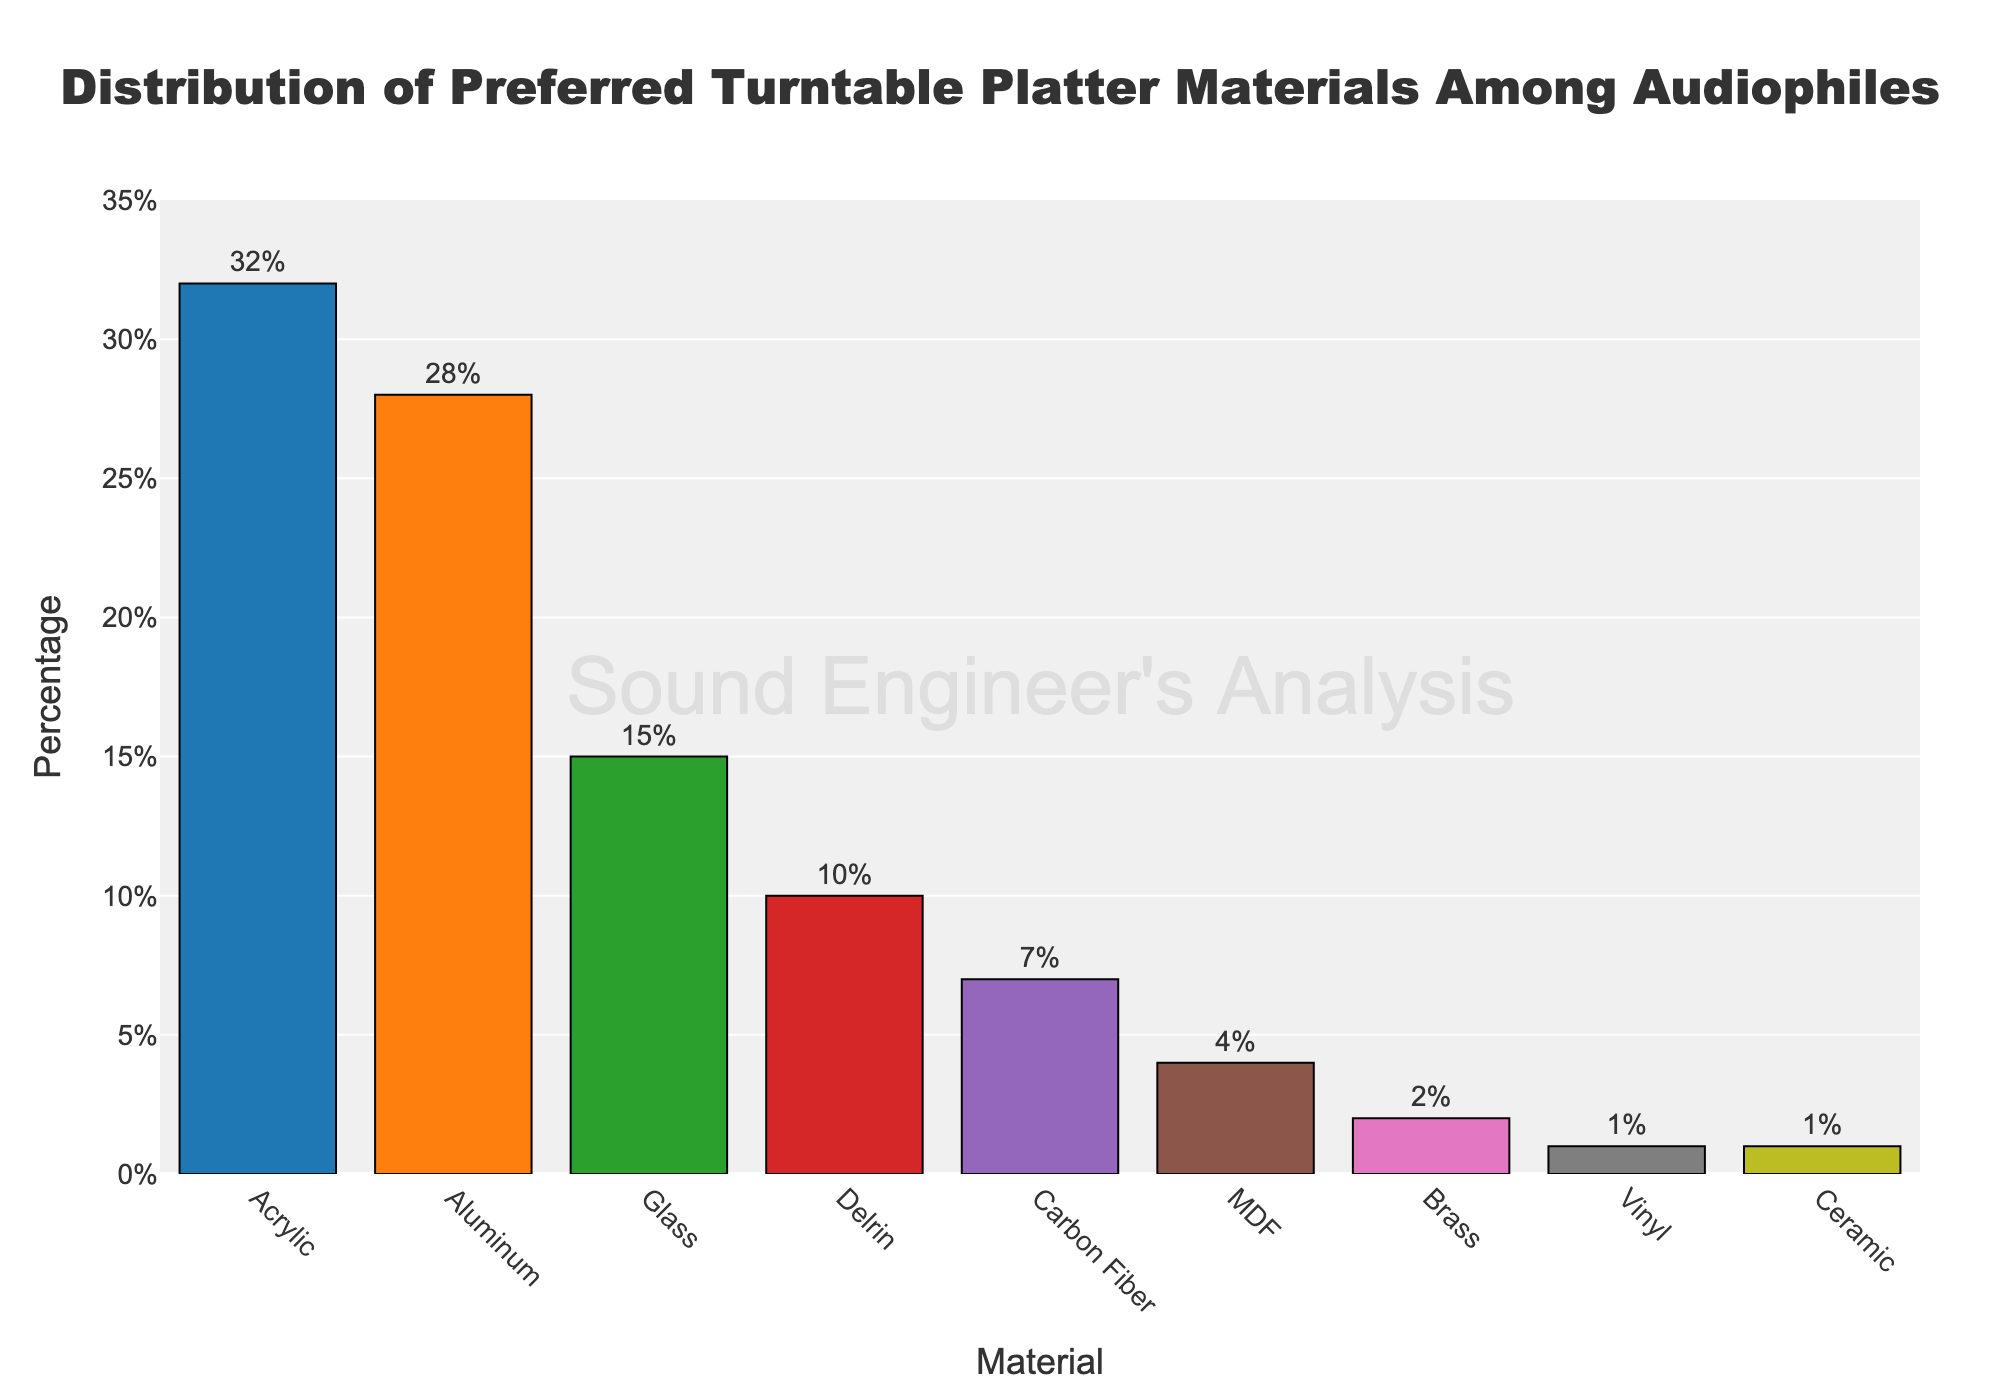Which material is preferred the most by audiophiles? The tallest bar represents the material preferred the most. The bar labeled "Acrylic" is the tallest with a height of 32%, indicating it is the most preferred material.
Answer: Acrylic Which two materials have the closest percentage of preference? By visually comparing the heights of the bars, the two bars labeled "Aluminum" and "Glass" seem to be closest in height. Aluminum has a percentage of 28% and Glass has 15%.
Answer: Aluminum and Glass What is the combined preference percentage for Acrylic and Aluminum? The percentage for Acrylic is 32% and for Aluminum is 28%. Add these two percentages together: 32% + 28% = 60%.
Answer: 60% By how much does Delrin's preference exceed Carbon Fiber's preference? Delrin's percentage is 10% and Carbon Fiber's is 7%. Subtract Carbon Fiber's percentage from Delrin's: 10% - 7% = 3%.
Answer: 3% Which material shows the least preference? The shortest bars represent the least preference. Both "Ceramic" and "Vinyl" have equally shortest bars with a height of 1%.
Answer: Ceramic and Vinyl What is the average preference percentage of the top three preferred materials? The top three materials are Acrylic (32%), Aluminum (28%), and Glass (15%). Calculating the average: (32 + 28 + 15) / 3 = 75 / 3 = 25%.
Answer: 25% What is the percentage difference between the most preferred (Acrylic) and the least preferred (Ceramic or Vinyl) material? The percentage for Acrylic is 32% and for Ceramic/Vinyl is 1%. Subtract the least preferred percentage from the most preferred: 32% - 1% = 31%.
Answer: 31% Which materials have a preference percentage greater than or equal to 10% but less than 20%? By scanning the bars, only one material falls within this range. Glass has a preference of 15%.
Answer: Glass How much more preferred is Acrylic over Delrin? Acrylic has a preference of 32% and Delrin has 10%. The difference is 32% - 10% = 22%.
Answer: 22% If you sum up the percentages of Carbon Fiber, MDF, Brass, Vinyl, and Ceramic, what is the total percentage? Adding the percentages for Carbon Fiber (7%), MDF (4%), Brass (2%), Vinyl (1%), and Ceramic (1%): 7 + 4 + 2 + 1 + 1 = 15%.
Answer: 15% 